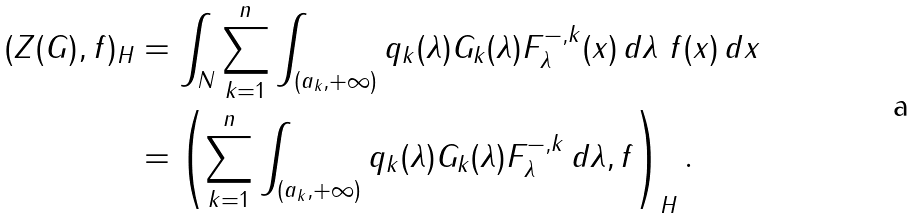<formula> <loc_0><loc_0><loc_500><loc_500>( Z ( G ) , f ) _ { H } & = \int _ { N } \sum _ { k = 1 } ^ { n } \int _ { ( a _ { k } , + \infty ) } q _ { k } ( \lambda ) G _ { k } ( \lambda ) F _ { \lambda } ^ { - , k } ( x ) \, d \lambda \ f ( x ) \, d x \\ & = \left ( \sum _ { k = 1 } ^ { n } \int _ { ( a _ { k } , + \infty ) } q _ { k } ( \lambda ) G _ { k } ( \lambda ) F _ { \lambda } ^ { - , k } \, d \lambda , f \right ) _ { H } .</formula> 